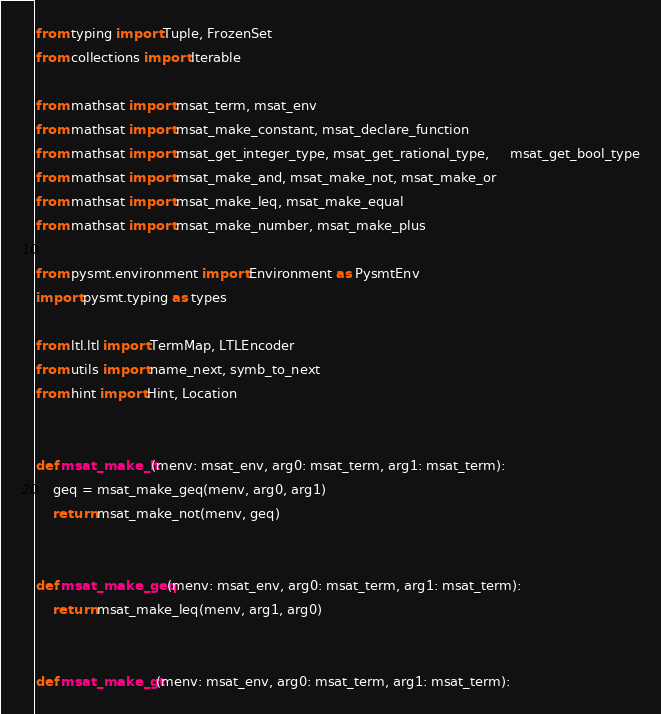Convert code to text. <code><loc_0><loc_0><loc_500><loc_500><_Python_>from typing import Tuple, FrozenSet
from collections import Iterable

from mathsat import msat_term, msat_env
from mathsat import msat_make_constant, msat_declare_function
from mathsat import msat_get_integer_type, msat_get_rational_type,     msat_get_bool_type
from mathsat import msat_make_and, msat_make_not, msat_make_or
from mathsat import msat_make_leq, msat_make_equal
from mathsat import msat_make_number, msat_make_plus

from pysmt.environment import Environment as PysmtEnv
import pysmt.typing as types

from ltl.ltl import TermMap, LTLEncoder
from utils import name_next, symb_to_next
from hint import Hint, Location


def msat_make_lt(menv: msat_env, arg0: msat_term, arg1: msat_term):
    geq = msat_make_geq(menv, arg0, arg1)
    return msat_make_not(menv, geq)


def msat_make_geq(menv: msat_env, arg0: msat_term, arg1: msat_term):
    return msat_make_leq(menv, arg1, arg0)


def msat_make_gt(menv: msat_env, arg0: msat_term, arg1: msat_term):</code> 